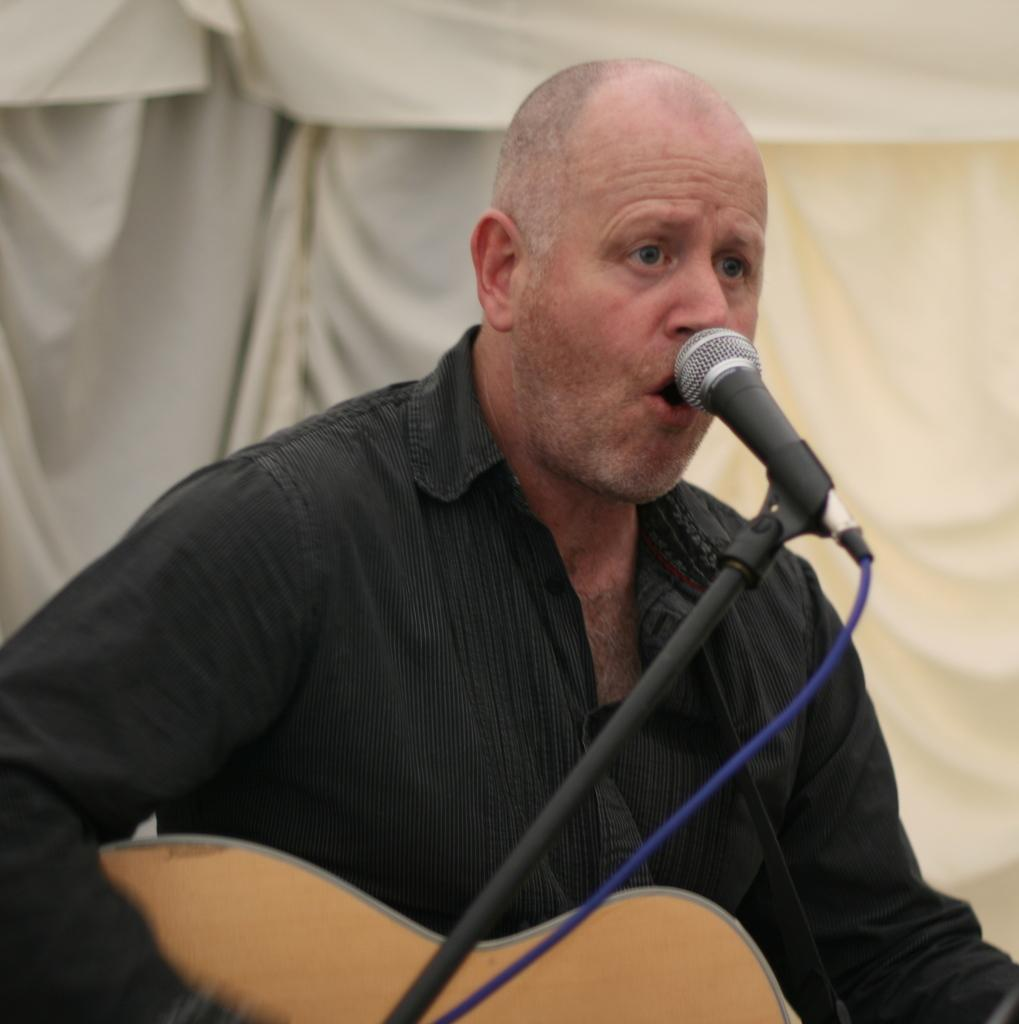What is the man in the image doing? The man is playing a guitar in the image. What object is present in the image that is typically used for amplifying sound? There is a microphone in the image, which is attached to a microphone stand. What can be seen in the backdrop of the image? There is a white cloth in the backdrop of the image. What type of apparatus is the chicken using to fly in the image? There is no chicken present in the image, so it is not possible to answer that question. 